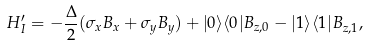Convert formula to latex. <formula><loc_0><loc_0><loc_500><loc_500>H _ { I } ^ { \prime } = - \frac { \Delta } { 2 } ( \sigma _ { x } B _ { x } + \sigma _ { y } B _ { y } ) + | 0 \rangle \langle 0 | B _ { z , 0 } - | 1 \rangle \langle 1 | B _ { z , 1 } ,</formula> 